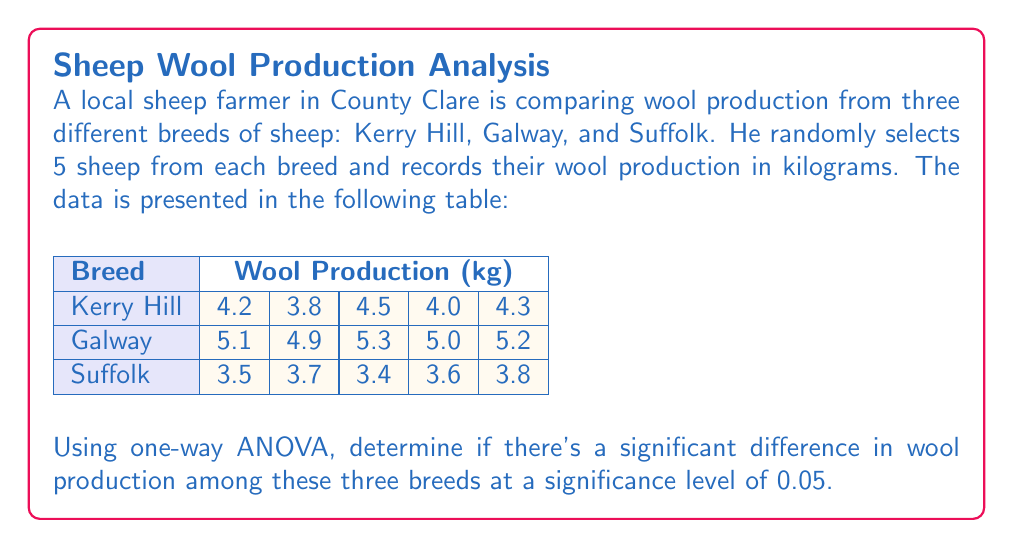Could you help me with this problem? To perform a one-way ANOVA, we need to follow these steps:

1. Calculate the sum of squares between groups (SSB), within groups (SSW), and total (SST).
2. Calculate the degrees of freedom for between groups (dfB), within groups (dfW), and total (dfT).
3. Calculate the mean squares for between groups (MSB) and within groups (MSW).
4. Calculate the F-statistic.
5. Compare the F-statistic with the critical F-value.

Step 1: Calculate sums of squares

First, we need to calculate the grand mean:
$$\bar{X} = \frac{(4.2 + 3.8 + ... + 3.8)}{15} = 4.353$$

SSB:
$$SSB = 5[(4.16 - 4.353)^2 + (5.1 - 4.353)^2 + (3.6 - 4.353)^2] = 7.0573$$

SSW:
$$SSW = [(4.2 - 4.16)^2 + (3.8 - 4.16)^2 + ... + (3.8 - 3.6)^2] = 0.4620$$

SST:
$$SST = SSB + SSW = 7.0573 + 0.4620 = 7.5193$$

Step 2: Calculate degrees of freedom

$$dfB = 3 - 1 = 2$$
$$dfW = 15 - 3 = 12$$
$$dfT = 15 - 1 = 14$$

Step 3: Calculate mean squares

$$MSB = \frac{SSB}{dfB} = \frac{7.0573}{2} = 3.5287$$
$$MSW = \frac{SSW}{dfW} = \frac{0.4620}{12} = 0.0385$$

Step 4: Calculate F-statistic

$$F = \frac{MSB}{MSW} = \frac{3.5287}{0.0385} = 91.65$$

Step 5: Compare with critical F-value

The critical F-value for $\alpha = 0.05$, $dfB = 2$, and $dfW = 12$ is approximately 3.89.

Since our calculated F-statistic (91.65) is greater than the critical F-value (3.89), we reject the null hypothesis.
Answer: There is a significant difference in wool production among the three breeds (F(2,12) = 91.65, p < 0.05). 